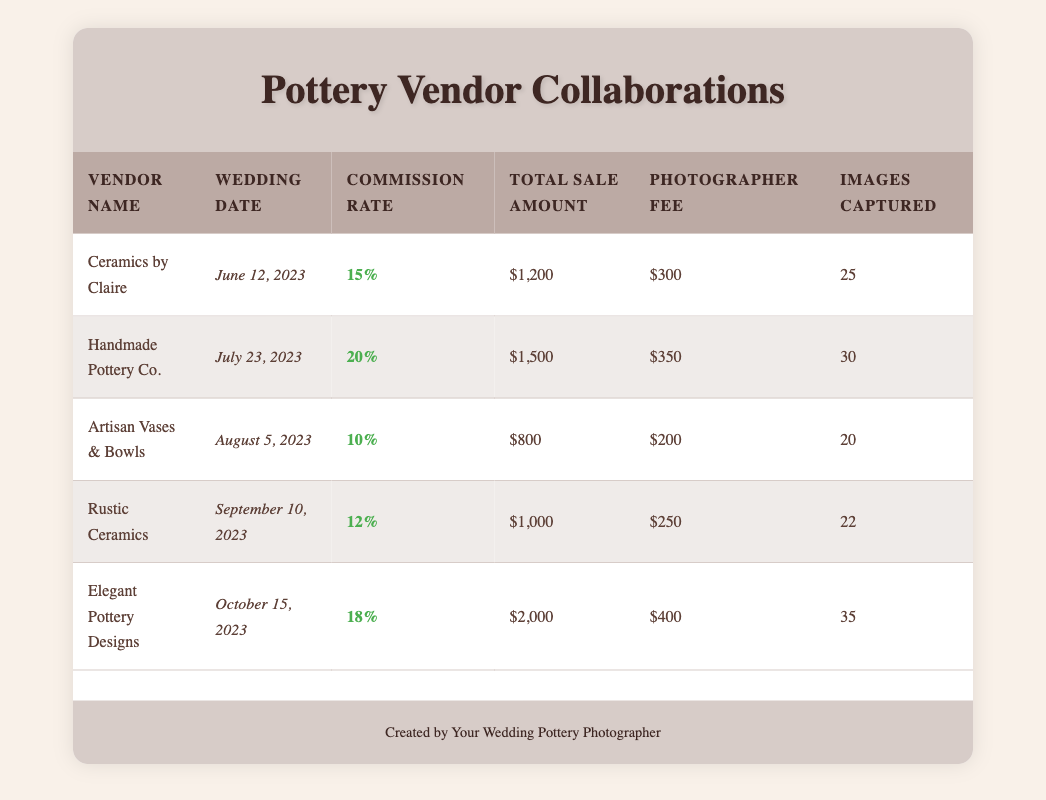What is the total sale amount for "Handmade Pottery Co."? The total sale amount for "Handmade Pottery Co." is located in the row corresponding to that vendor. It can be found in the fourth column of their row, and it states "$1,500".
Answer: $1,500 What is the commission rate for "Elegant Pottery Designs"? The commission rate for "Elegant Pottery Designs" is found in the third column of their row in the table, which indicates "18%".
Answer: 18% Who had the maximum number of images captured during a wedding? To determine who had the most images captured, we need to look at the sixth column for each vendor's row. "Elegant Pottery Designs" captured 35 images, which is the highest compared to other vendors.
Answer: Elegant Pottery Designs What is the average commission rate across all vendors? To find the average commission rate, we add all the commission rates together: (15 + 20 + 10 + 12 + 18) = 75. This sum is then divided by the number of vendors, which is 5: 75/5 = 15%.
Answer: 15% Is the total sale amount for "Artisan Vases & Bowls" greater than $900? We find the total sale amount for "Artisan Vases & Bowls" in the table, which is "$800". Since $800 is less than $900, the answer is no.
Answer: No What is the total photographer fee for all collaborations combined? To calculate the total photographer fee, we need to add the fees from all vendors: (300 + 350 + 200 + 250 + 400) = 1500.
Answer: $1,500 Which vendor had the lowest total sale amount? By looking at the total sale amounts in the fourth column, "Artisan Vases & Bowls" has the lowest amount at "$800".
Answer: Artisan Vases & Bowls Did any vendor collaborate for a wedding on September 10, 2023? By checking the wedding dates in the second column, we can see that "Rustic Ceramics" collaborated on that exact date, so the answer is yes.
Answer: Yes What is the difference in the total sale amounts between "Ceramics by Claire" and "Elegant Pottery Designs"? The total sale amount for "Ceramics by Claire" is "$1,200" and for "Elegant Pottery Designs" it is "$2,000". The difference is calculated as $2,000 - $1,200 = $800.
Answer: $800 